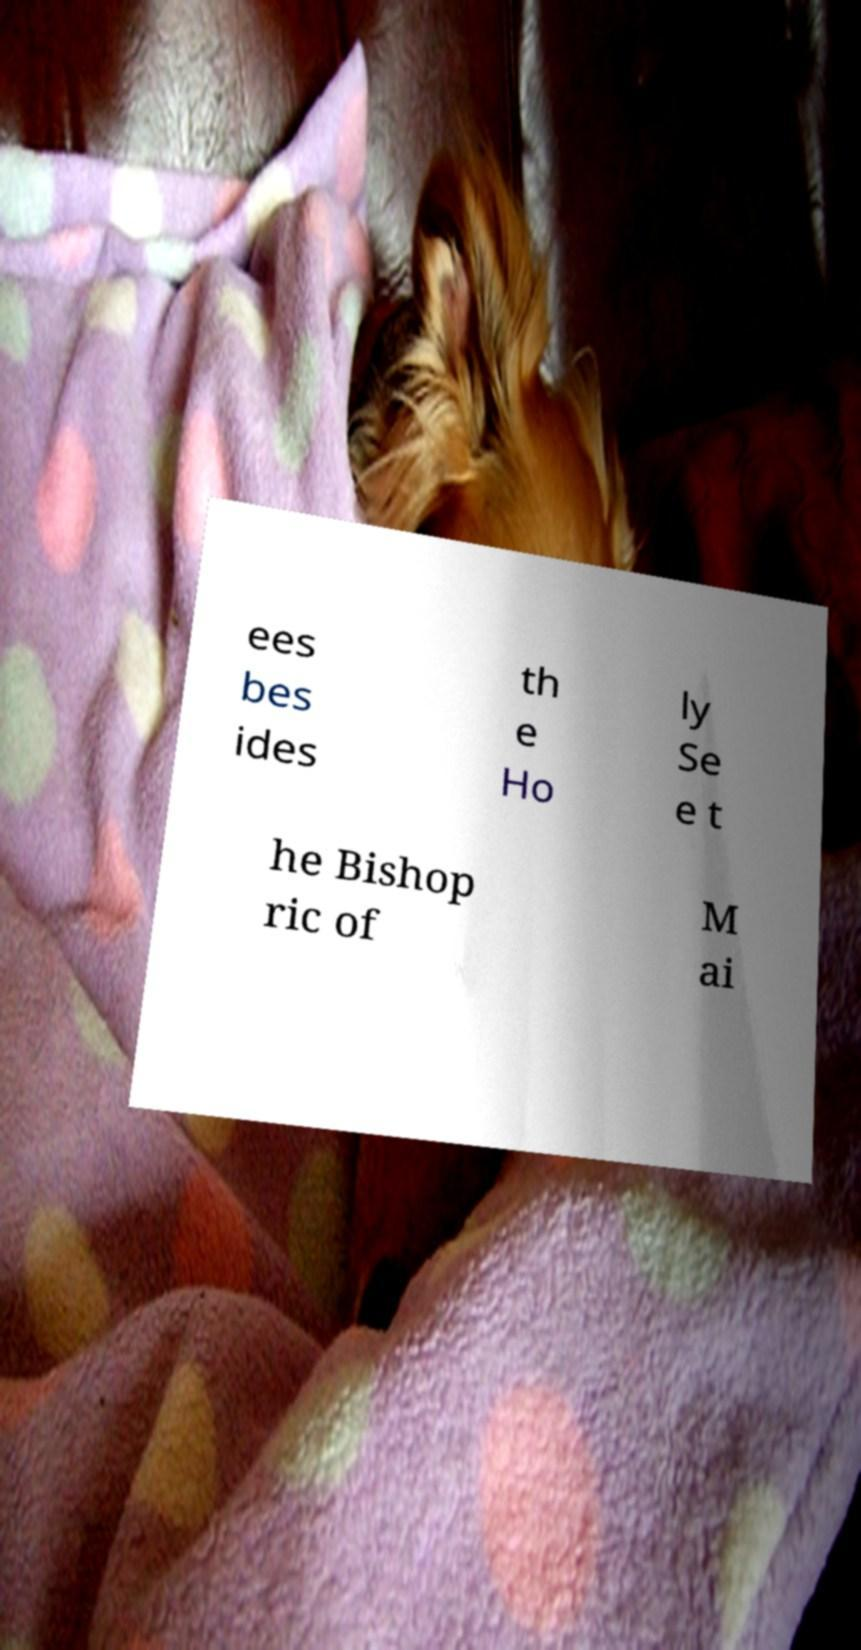What messages or text are displayed in this image? I need them in a readable, typed format. ees bes ides th e Ho ly Se e t he Bishop ric of M ai 